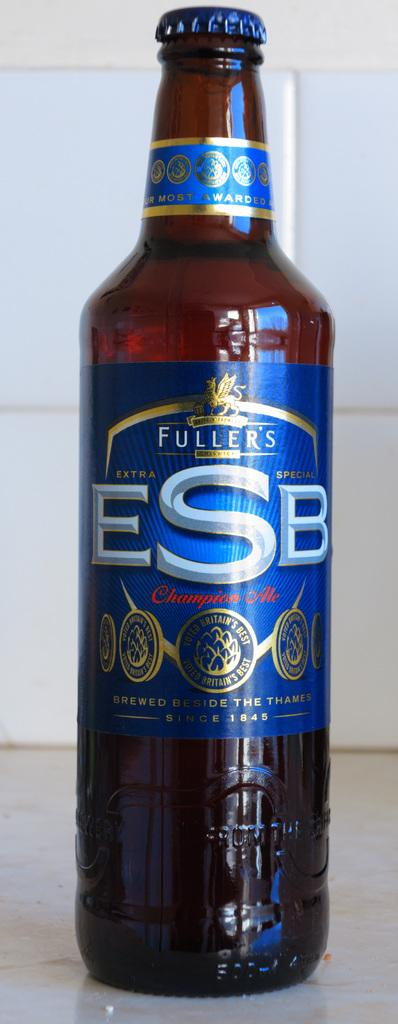<image>
Provide a brief description of the given image. a bottle of ESB sits on a counter unopened 